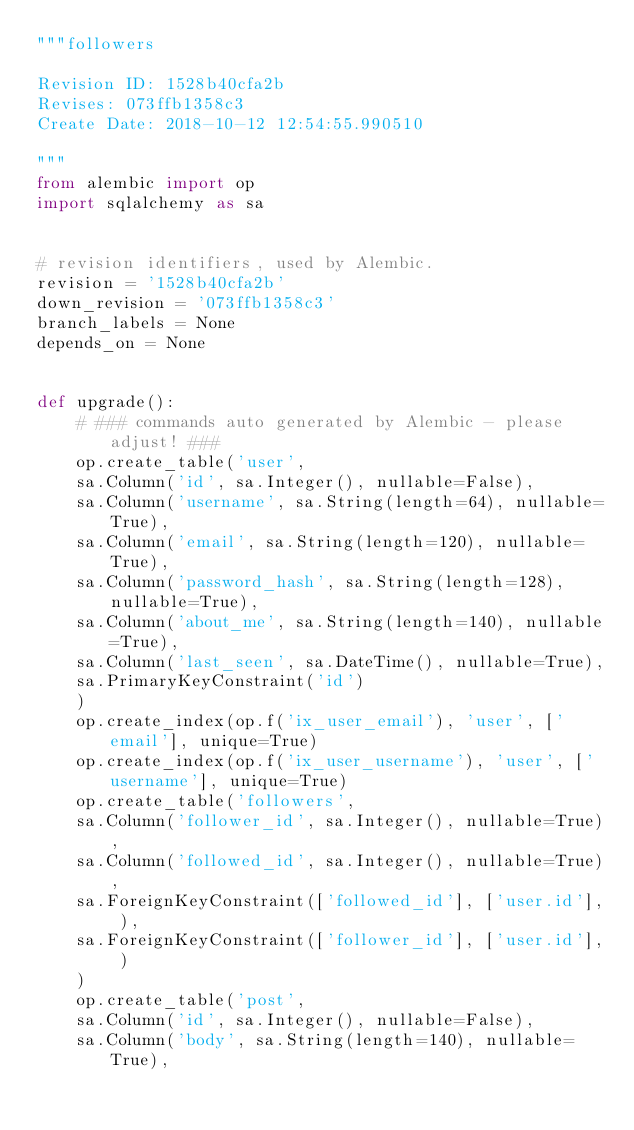Convert code to text. <code><loc_0><loc_0><loc_500><loc_500><_Python_>"""followers

Revision ID: 1528b40cfa2b
Revises: 073ffb1358c3
Create Date: 2018-10-12 12:54:55.990510

"""
from alembic import op
import sqlalchemy as sa


# revision identifiers, used by Alembic.
revision = '1528b40cfa2b'
down_revision = '073ffb1358c3'
branch_labels = None
depends_on = None


def upgrade():
    # ### commands auto generated by Alembic - please adjust! ###
    op.create_table('user',
    sa.Column('id', sa.Integer(), nullable=False),
    sa.Column('username', sa.String(length=64), nullable=True),
    sa.Column('email', sa.String(length=120), nullable=True),
    sa.Column('password_hash', sa.String(length=128), nullable=True),
    sa.Column('about_me', sa.String(length=140), nullable=True),
    sa.Column('last_seen', sa.DateTime(), nullable=True),
    sa.PrimaryKeyConstraint('id')
    )
    op.create_index(op.f('ix_user_email'), 'user', ['email'], unique=True)
    op.create_index(op.f('ix_user_username'), 'user', ['username'], unique=True)
    op.create_table('followers',
    sa.Column('follower_id', sa.Integer(), nullable=True),
    sa.Column('followed_id', sa.Integer(), nullable=True),
    sa.ForeignKeyConstraint(['followed_id'], ['user.id'], ),
    sa.ForeignKeyConstraint(['follower_id'], ['user.id'], )
    )
    op.create_table('post',
    sa.Column('id', sa.Integer(), nullable=False),
    sa.Column('body', sa.String(length=140), nullable=True),</code> 